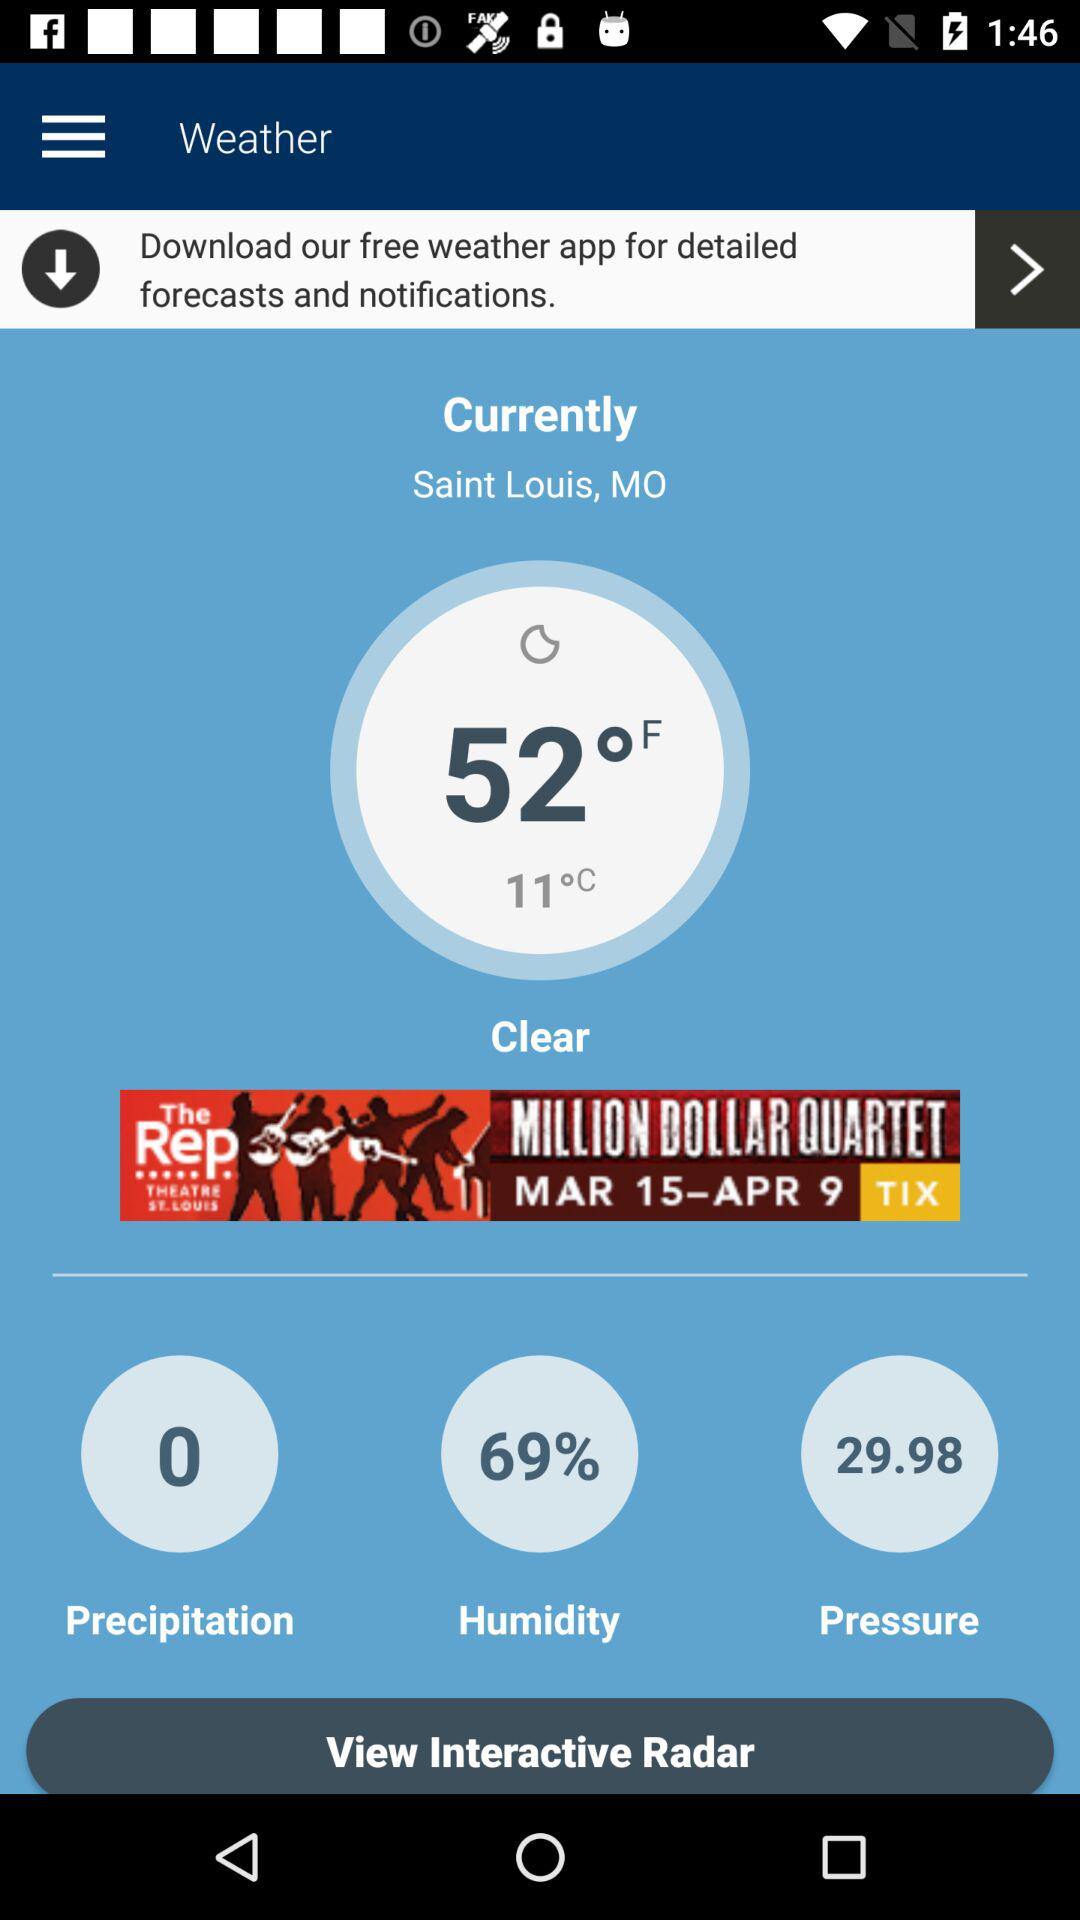How many degrees Celsius is the current temperature?
Answer the question using a single word or phrase. 11°C 